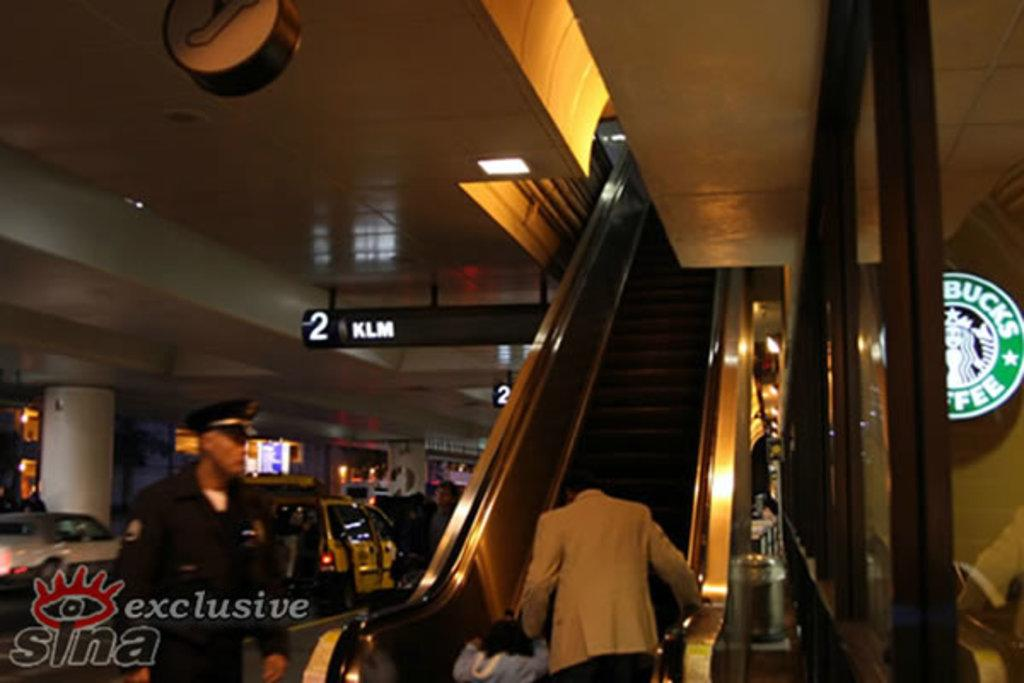<image>
Summarize the visual content of the image. Several patrons ride an escalator upwards past a Starbucks sign. 